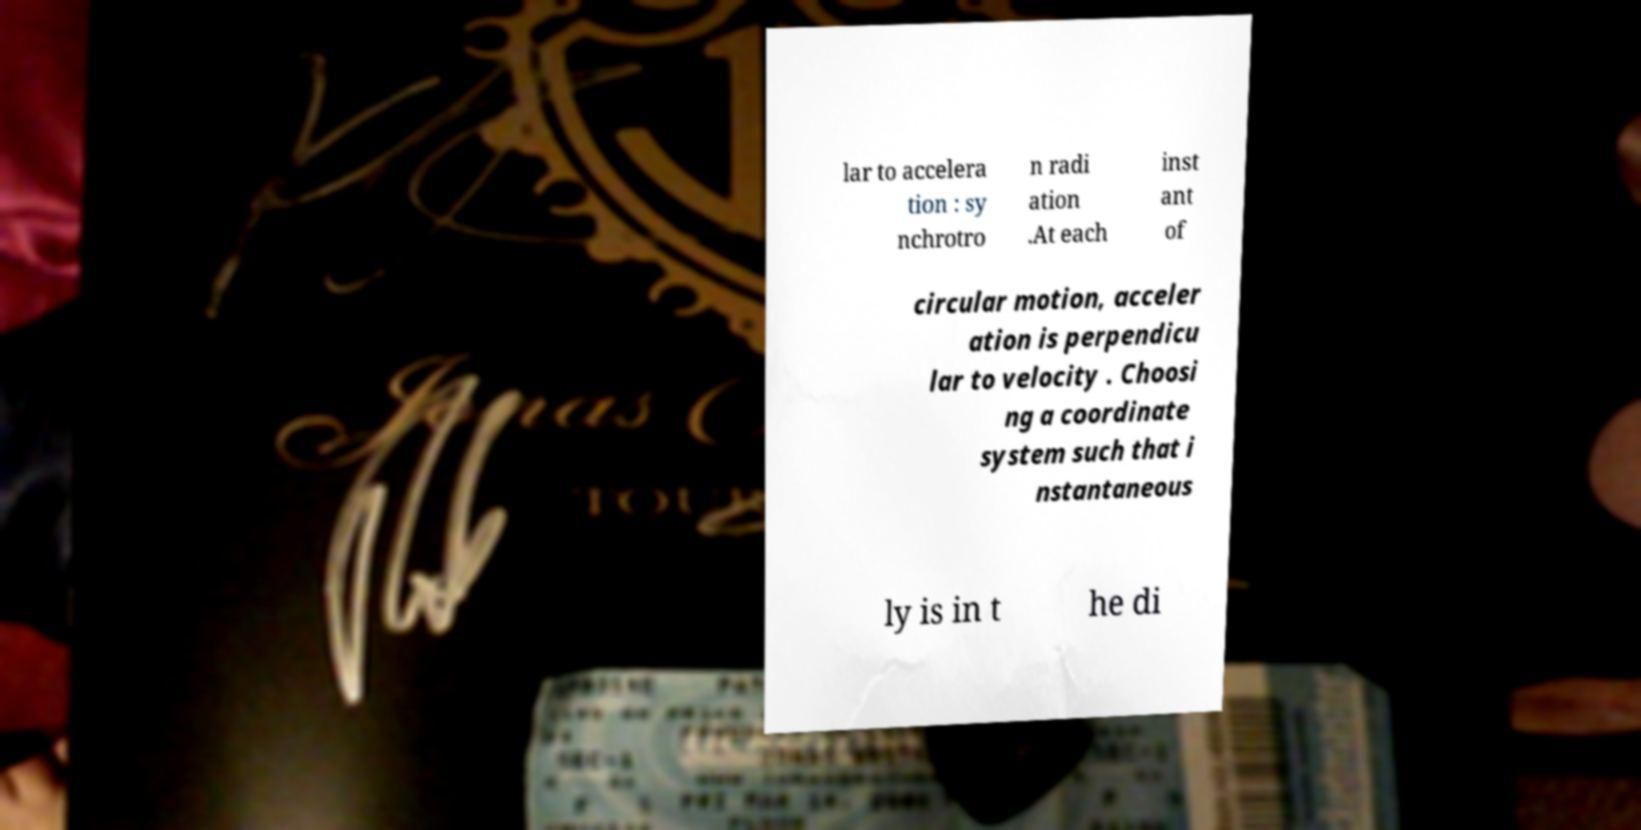Can you accurately transcribe the text from the provided image for me? lar to accelera tion : sy nchrotro n radi ation .At each inst ant of circular motion, acceler ation is perpendicu lar to velocity . Choosi ng a coordinate system such that i nstantaneous ly is in t he di 